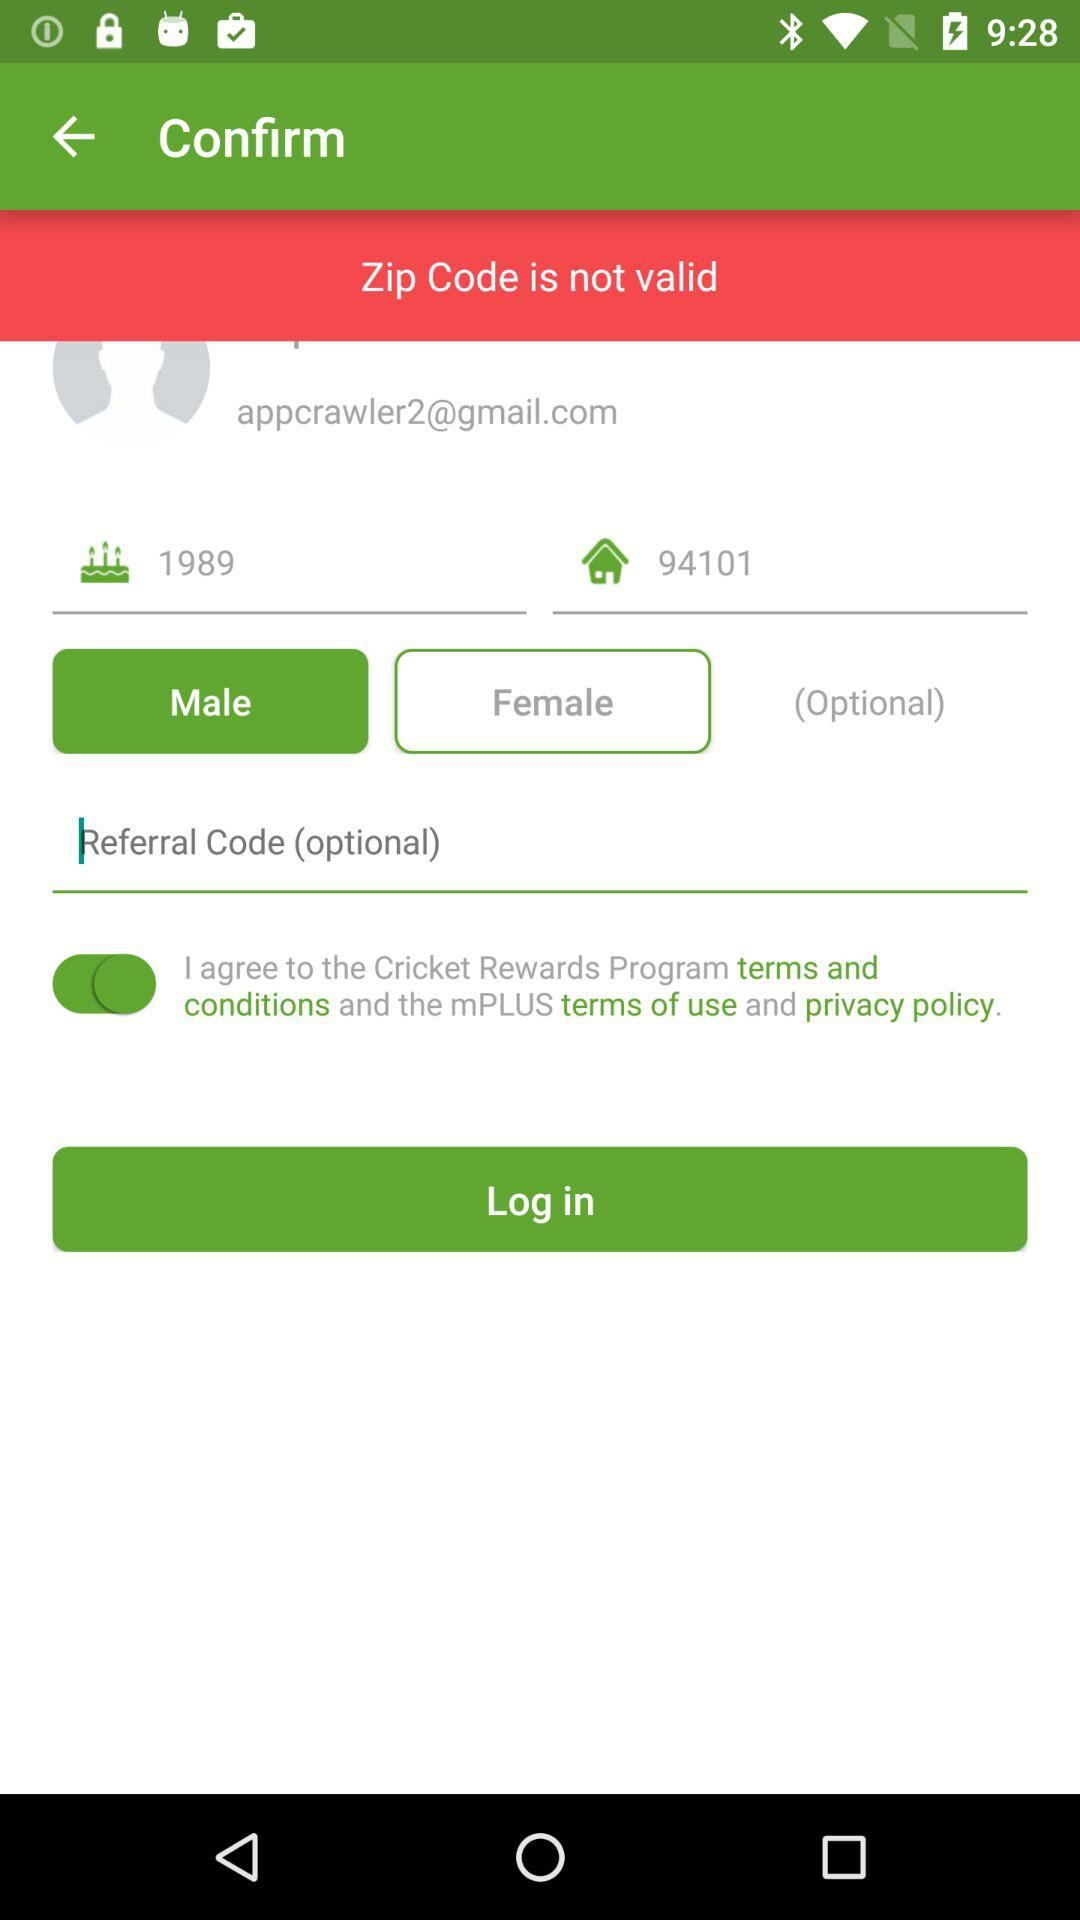What is the status of the option that includes agreement to the “terms and conditions”? The status is "on". 